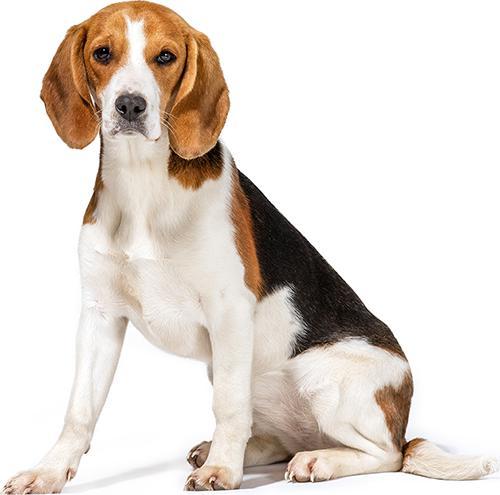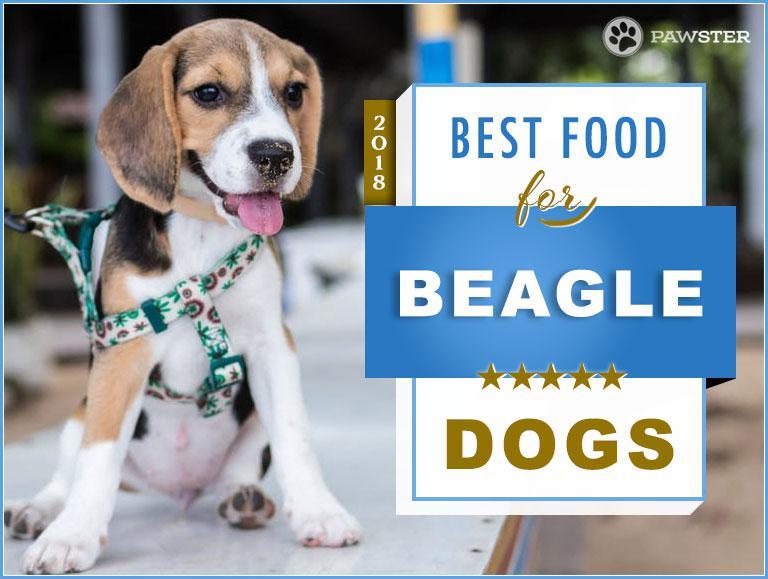The first image is the image on the left, the second image is the image on the right. For the images displayed, is the sentence "An image shows at least one beagle dog eating from a bowl." factually correct? Answer yes or no. No. The first image is the image on the left, the second image is the image on the right. Given the left and right images, does the statement "At least one beagle is eating out of a bowl." hold true? Answer yes or no. No. 